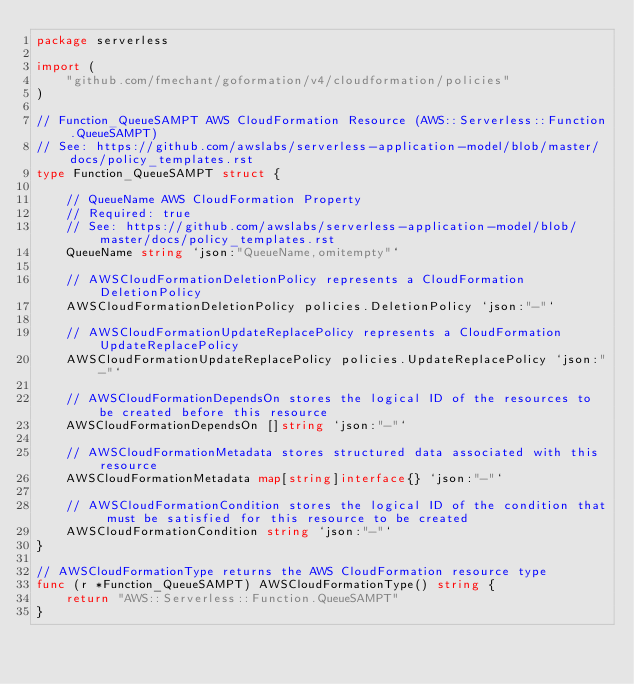<code> <loc_0><loc_0><loc_500><loc_500><_Go_>package serverless

import (
	"github.com/fmechant/goformation/v4/cloudformation/policies"
)

// Function_QueueSAMPT AWS CloudFormation Resource (AWS::Serverless::Function.QueueSAMPT)
// See: https://github.com/awslabs/serverless-application-model/blob/master/docs/policy_templates.rst
type Function_QueueSAMPT struct {

	// QueueName AWS CloudFormation Property
	// Required: true
	// See: https://github.com/awslabs/serverless-application-model/blob/master/docs/policy_templates.rst
	QueueName string `json:"QueueName,omitempty"`

	// AWSCloudFormationDeletionPolicy represents a CloudFormation DeletionPolicy
	AWSCloudFormationDeletionPolicy policies.DeletionPolicy `json:"-"`

	// AWSCloudFormationUpdateReplacePolicy represents a CloudFormation UpdateReplacePolicy
	AWSCloudFormationUpdateReplacePolicy policies.UpdateReplacePolicy `json:"-"`

	// AWSCloudFormationDependsOn stores the logical ID of the resources to be created before this resource
	AWSCloudFormationDependsOn []string `json:"-"`

	// AWSCloudFormationMetadata stores structured data associated with this resource
	AWSCloudFormationMetadata map[string]interface{} `json:"-"`

	// AWSCloudFormationCondition stores the logical ID of the condition that must be satisfied for this resource to be created
	AWSCloudFormationCondition string `json:"-"`
}

// AWSCloudFormationType returns the AWS CloudFormation resource type
func (r *Function_QueueSAMPT) AWSCloudFormationType() string {
	return "AWS::Serverless::Function.QueueSAMPT"
}
</code> 